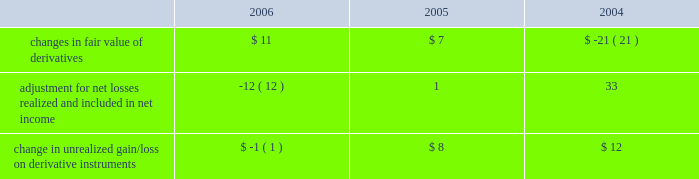Notes to consolidated financial statements ( continued ) note 8 2014shareholders 2019 equity ( continued ) the table summarizes activity in other comprehensive income related to derivatives , net of taxes , held by the company ( in millions ) : .
The tax effect related to the changes in fair value of derivatives was $ ( 8 ) million , $ ( 3 ) million , and $ 10 million for 2006 , 2005 , and 2004 , respectively .
The tax effect related to derivative gains/losses reclassified from other comprehensive income to net income was $ 8 million , $ ( 2 ) million , and $ ( 13 ) million for 2006 , 2005 , and 2004 , respectively .
Employee benefit plans 2003 employee stock plan the 2003 employee stock plan ( the 201c2003 plan 201d ) is a shareholder approved plan that provides for broad- based grants to employees , including executive officers .
Based on the terms of individual option grants , options granted under the 2003 plan generally expire 7 to 10 years after the grant date and generally become exercisable over a period of 4 years , based on continued employment , with either annual or quarterly vesting .
The 2003 plan permits the granting of incentive stock options , nonstatutory stock options , restricted stock units , stock appreciation rights , and stock purchase rights .
1997 employee stock option plan in august 1997 , the company 2019s board of directors approved the 1997 employee stock option plan ( the 201c1997 plan 201d ) , a non-shareholder approved plan for grants of stock options to employees who are not officers of the company .
Based on the terms of individual option grants , options granted under the 1997 plan generally expire 7 to 10 years after the grant date and generally become exercisable over a period of 4 years , based on continued employment , with either annual or quarterly vesting .
In october 2003 , the company terminated the 1997 employee stock option plan and cancelled all remaining unissued shares totaling 28590702 .
No new options can be granted from the 1997 plan .
Employee stock option exchange program on march 20 , 2003 , the company announced a voluntary employee stock option exchange program ( the 201cexchange program 201d ) whereby eligible employees , other than executive officers and members of the board of directors , had an opportunity to exchange outstanding options with exercise prices at or above $ 12.50 per share for a predetermined smaller number of new stock options issued with exercise prices equal to the fair market value of one share of the company 2019s common stock on the day the new awards were issued , which was to be at least six months plus one day after the exchange options were cancelled .
On april 17 , 2003 , in accordance with the exchange program , the company cancelled options to purchase 33138386 shares of its common stock .
On october 22 , 2003 , new stock options totaling 13394736 shares were issued to employees at an exercise price of $ 11.38 per share , which is equivalent to the closing price of the company 2019s stock on that date .
No financial or accounting impact to the company 2019s financial position , results of operations or cash flows was associated with this transaction. .
What was the greatest annual change in unrealized gain/loss on derivative instruments , in millions?/? 
Computations: table_max(change in unrealized gain/loss on derivative instruments, none)
Answer: 12.0. 